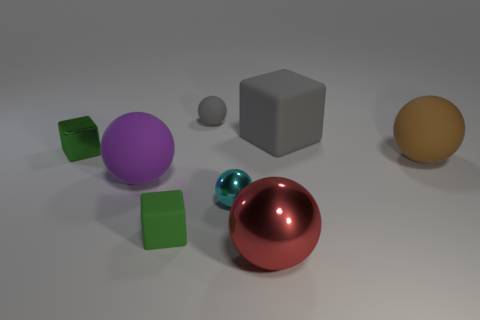What number of things are brown metallic things or tiny metallic objects that are to the right of the tiny gray ball?
Offer a very short reply. 1. Are there fewer green metal blocks than cyan metal cubes?
Provide a short and direct response. No. The sphere behind the tiny object to the left of the rubber cube in front of the large brown rubber object is what color?
Your answer should be compact. Gray. Is the material of the red ball the same as the small gray object?
Keep it short and to the point. No. How many gray blocks are on the left side of the green shiny block?
Your response must be concise. 0. What size is the red thing that is the same shape as the brown object?
Provide a short and direct response. Large. What number of blue things are tiny metal blocks or small shiny spheres?
Keep it short and to the point. 0. What number of tiny spheres are in front of the tiny gray rubber ball behind the large shiny sphere?
Make the answer very short. 1. What number of other things are the same shape as the big red object?
Your answer should be compact. 4. There is a large cube that is the same color as the tiny rubber ball; what is its material?
Provide a succinct answer. Rubber. 